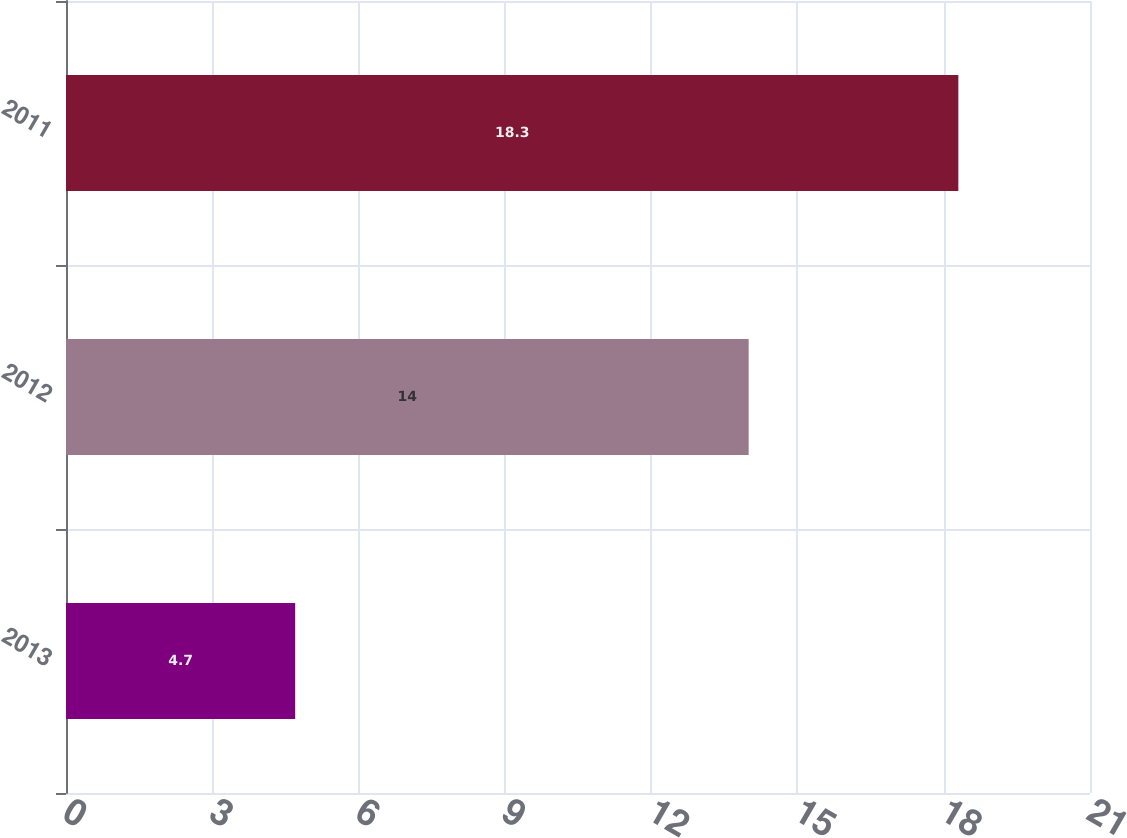<chart> <loc_0><loc_0><loc_500><loc_500><bar_chart><fcel>2013<fcel>2012<fcel>2011<nl><fcel>4.7<fcel>14<fcel>18.3<nl></chart> 